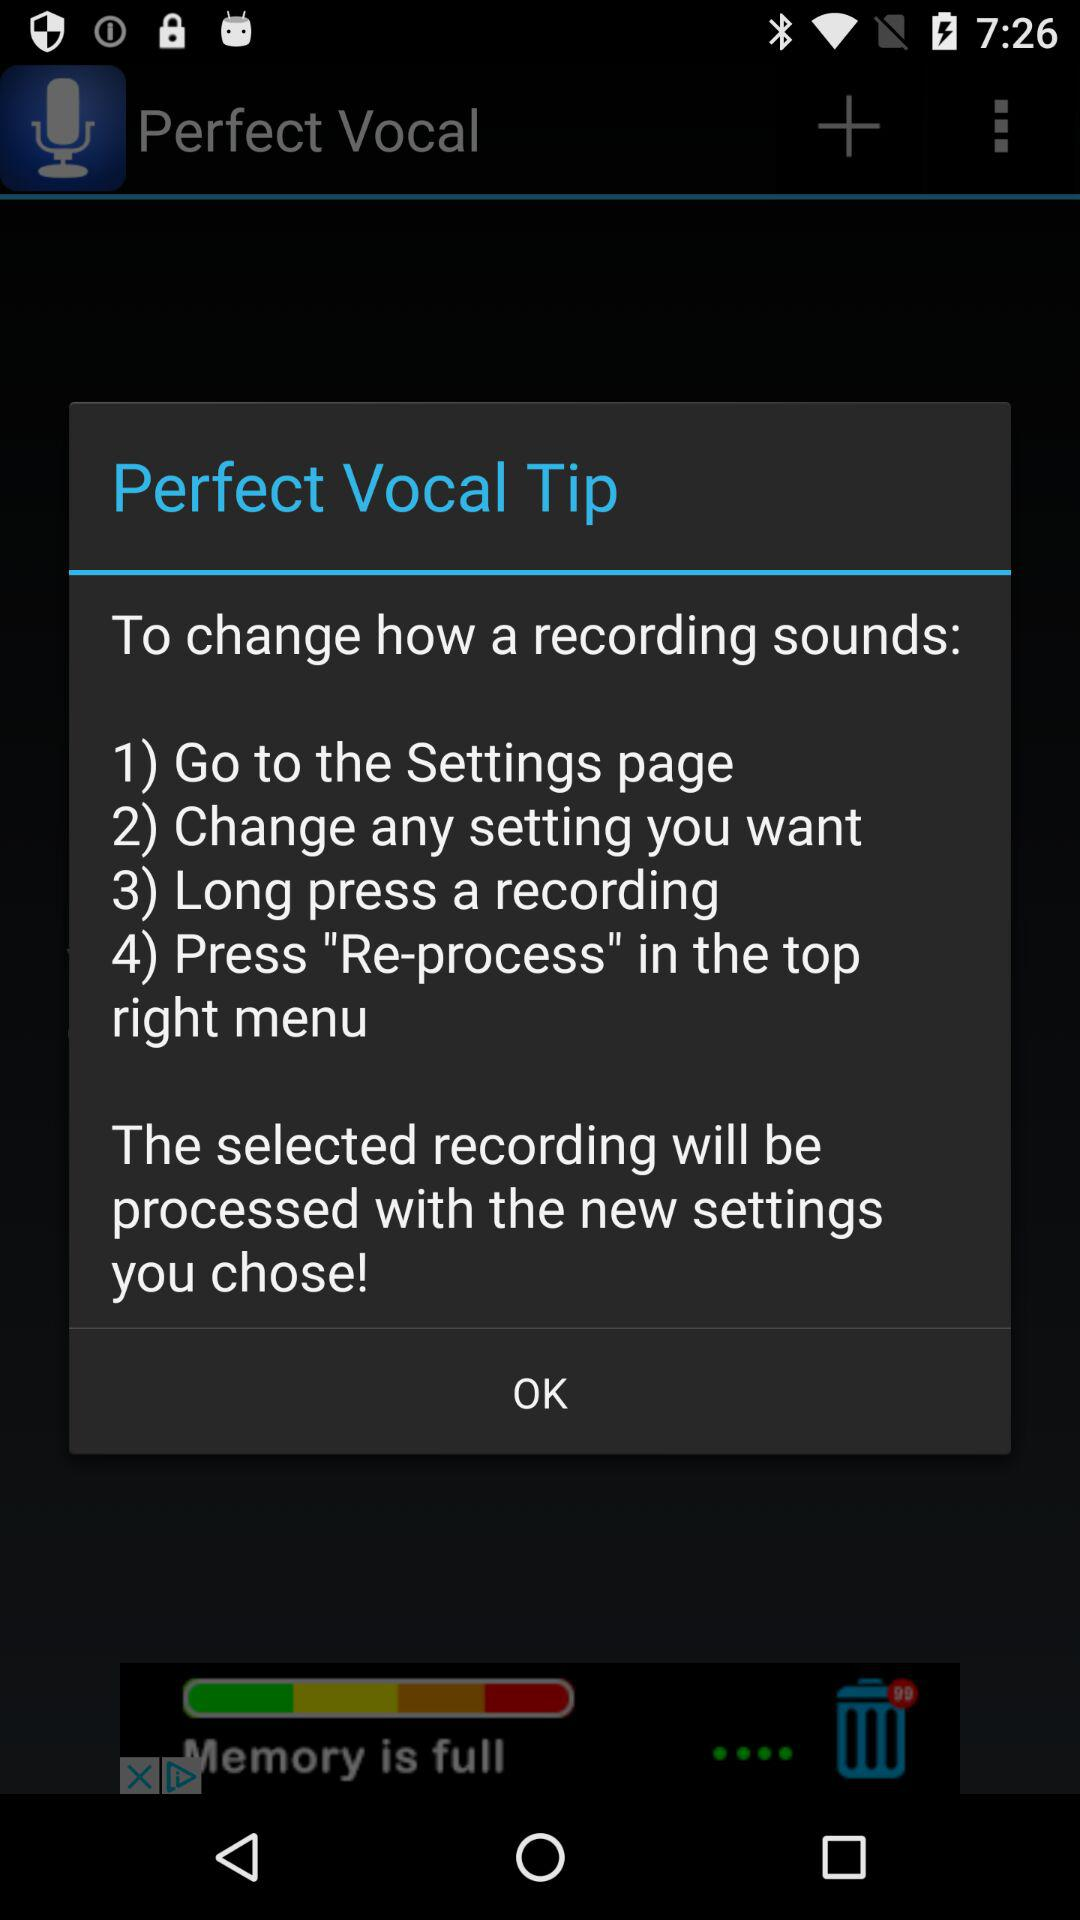What is the app name? The app name is "Perfect Vocal". 